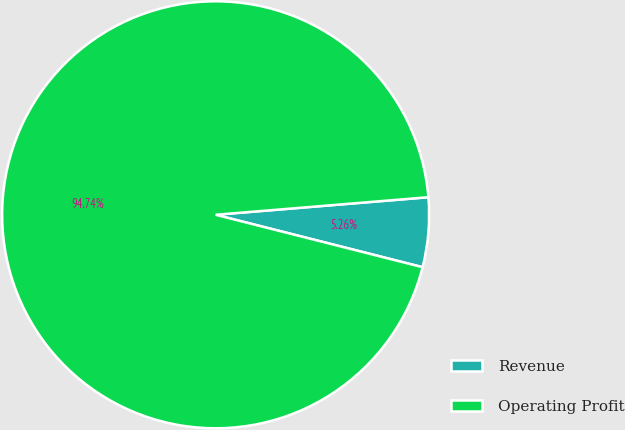Convert chart to OTSL. <chart><loc_0><loc_0><loc_500><loc_500><pie_chart><fcel>Revenue<fcel>Operating Profit<nl><fcel>5.26%<fcel>94.74%<nl></chart> 